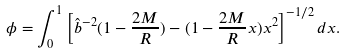Convert formula to latex. <formula><loc_0><loc_0><loc_500><loc_500>\phi = \int _ { 0 } ^ { 1 } \left [ \hat { b } ^ { - 2 } ( 1 - \frac { 2 M } { R } ) - ( 1 - \frac { 2 M } { R } x ) x ^ { 2 } \right ] ^ { - 1 / 2 } d x .</formula> 